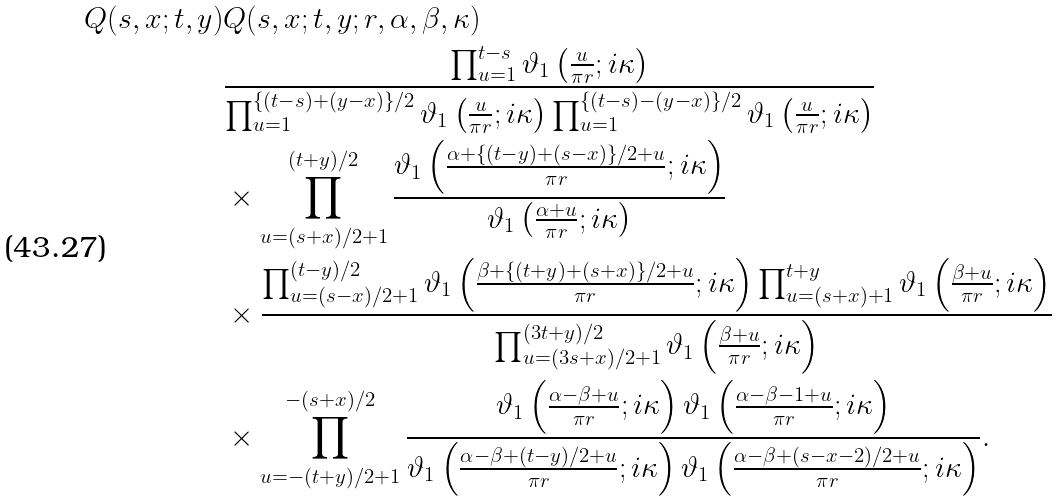Convert formula to latex. <formula><loc_0><loc_0><loc_500><loc_500>Q ( s , x ; t , y ) & Q ( s , x ; t , y ; r , \alpha , \beta , \kappa ) \\ & \frac { \prod _ { u = 1 } ^ { t - s } \vartheta _ { 1 } \left ( \frac { u } { \pi r } ; i \kappa \right ) } { \prod _ { u = 1 } ^ { \{ ( t - s ) + ( y - x ) \} / 2 } \vartheta _ { 1 } \left ( \frac { u } { \pi r } ; i \kappa \right ) \prod _ { u = 1 } ^ { \{ ( t - s ) - ( y - x ) \} / 2 } \vartheta _ { 1 } \left ( \frac { u } { \pi r } ; i \kappa \right ) } \\ & \times \prod _ { u = ( s + x ) / 2 + 1 } ^ { ( t + y ) / 2 } \frac { \vartheta _ { 1 } \left ( \frac { \alpha + \{ ( t - y ) + ( s - x ) \} / 2 + u } { \pi r } ; i \kappa \right ) } { \vartheta _ { 1 } \left ( \frac { \alpha + u } { \pi r } ; i \kappa \right ) } \\ & \times \frac { \prod _ { u = ( s - x ) / 2 + 1 } ^ { ( t - y ) / 2 } \vartheta _ { 1 } \left ( \frac { \beta + \{ ( t + y ) + ( s + x ) \} / 2 + u } { \pi r } ; i \kappa \right ) \prod _ { u = ( s + x ) + 1 } ^ { t + y } \vartheta _ { 1 } \left ( \frac { \beta + u } { \pi r } ; i \kappa \right ) } { \prod _ { u = ( 3 s + x ) / 2 + 1 } ^ { ( 3 t + y ) / 2 } \vartheta _ { 1 } \left ( \frac { \beta + u } { \pi r } ; i \kappa \right ) } \\ & \times \prod _ { u = - ( t + y ) / 2 + 1 } ^ { - ( s + x ) / 2 } \frac { \vartheta _ { 1 } \left ( \frac { \alpha - \beta + u } { \pi r } ; i \kappa \right ) \vartheta _ { 1 } \left ( \frac { \alpha - \beta - 1 + u } { \pi r } ; i \kappa \right ) } { \vartheta _ { 1 } \left ( \frac { \alpha - \beta + ( t - y ) / 2 + u } { \pi r } ; i \kappa \right ) \vartheta _ { 1 } \left ( \frac { \alpha - \beta + ( s - x - 2 ) / 2 + u } { \pi r } ; i \kappa \right ) } .</formula> 